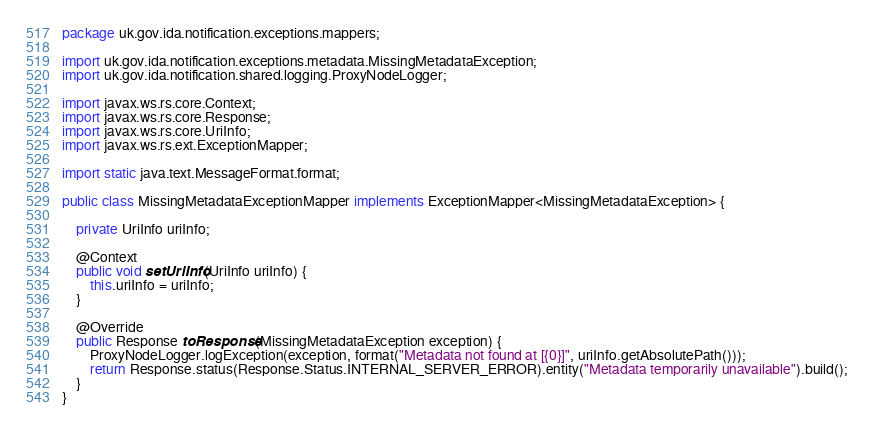<code> <loc_0><loc_0><loc_500><loc_500><_Java_>package uk.gov.ida.notification.exceptions.mappers;

import uk.gov.ida.notification.exceptions.metadata.MissingMetadataException;
import uk.gov.ida.notification.shared.logging.ProxyNodeLogger;

import javax.ws.rs.core.Context;
import javax.ws.rs.core.Response;
import javax.ws.rs.core.UriInfo;
import javax.ws.rs.ext.ExceptionMapper;

import static java.text.MessageFormat.format;

public class MissingMetadataExceptionMapper implements ExceptionMapper<MissingMetadataException> {

    private UriInfo uriInfo;

    @Context
    public void setUriInfo(UriInfo uriInfo) {
        this.uriInfo = uriInfo;
    }

    @Override
    public Response toResponse(MissingMetadataException exception) {
        ProxyNodeLogger.logException(exception, format("Metadata not found at [{0}]", uriInfo.getAbsolutePath()));
        return Response.status(Response.Status.INTERNAL_SERVER_ERROR).entity("Metadata temporarily unavailable").build();
    }
}
</code> 